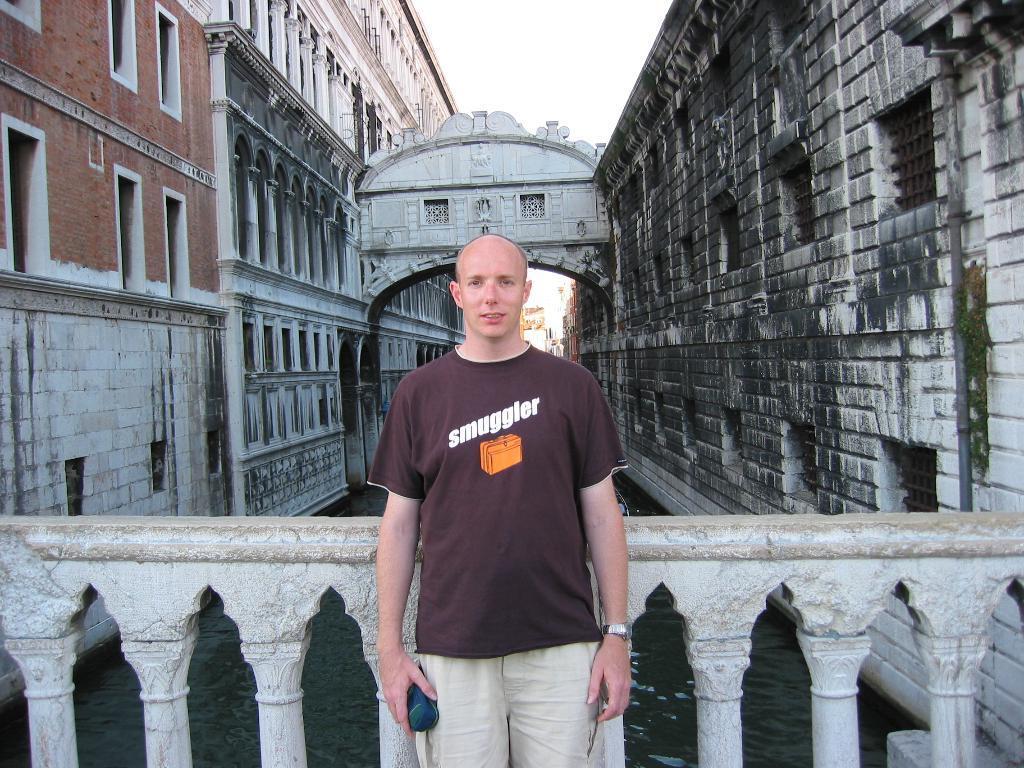How would you summarize this image in a sentence or two? In this picture I see a man in the front who is standing and I see buildings on the both sides and I see the water in the middle of this picture and I see the sky. 